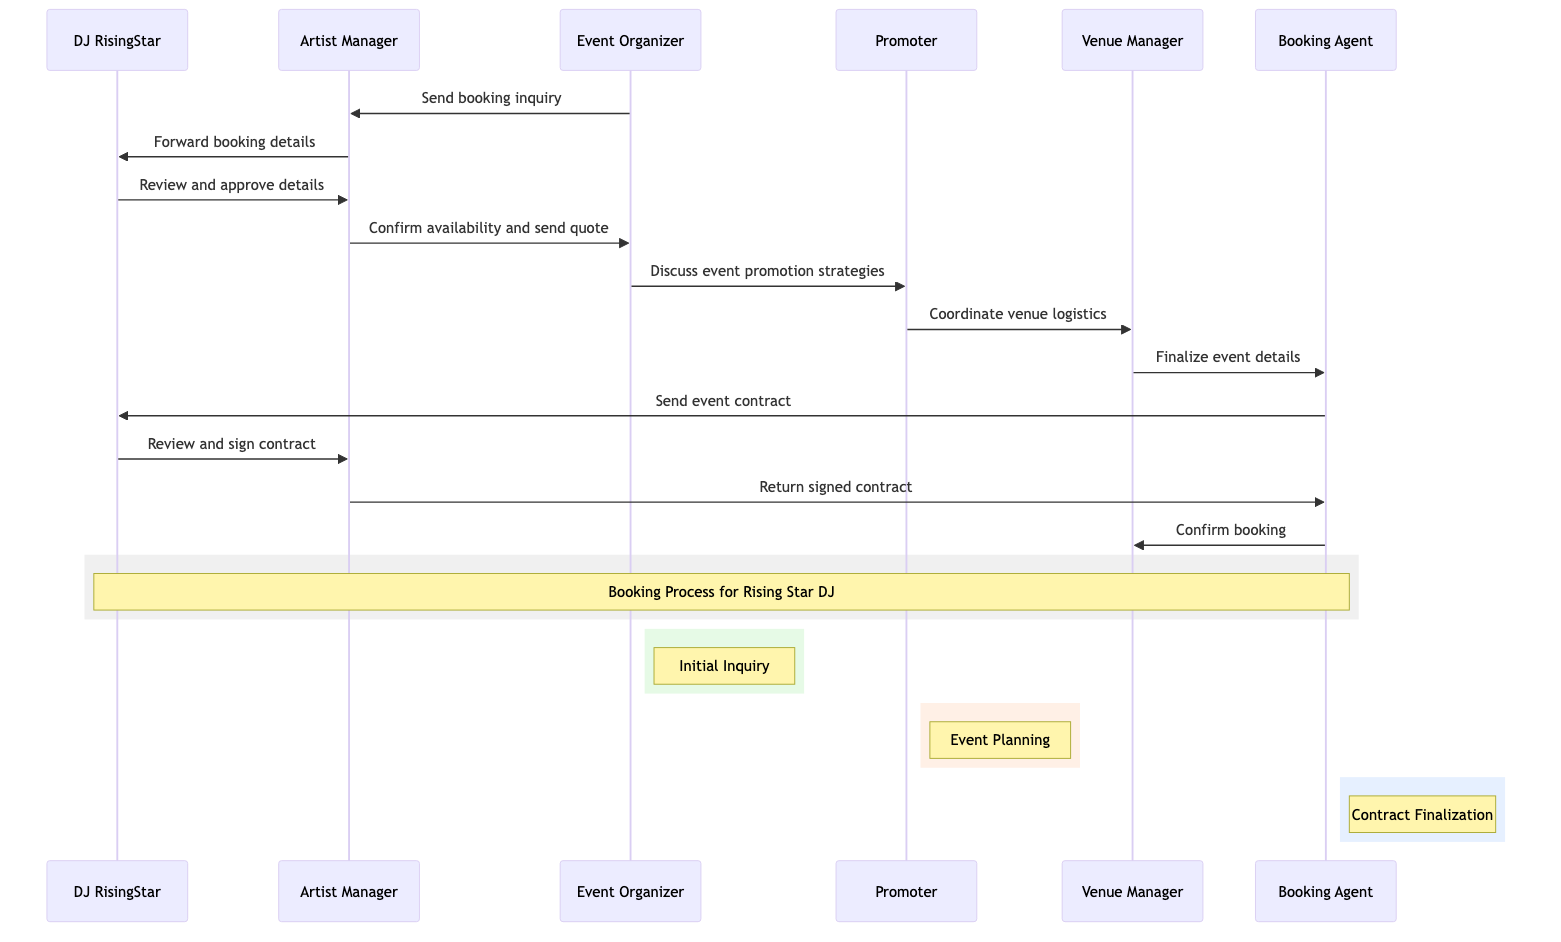What are the participants in the booking process? The participants listed in the diagram are DJ RisingStar, Artist Manager, Event Organizer, Promoter, Venue Manager, and Booking Agent. This information can be obtained directly from the participant section of the sequence diagram.
Answer: DJ RisingStar, Artist Manager, Event Organizer, Promoter, Venue Manager, Booking Agent Who sends the booking inquiry? The diagram indicates that the Event Organizer is the one who sends the booking inquiry to the Artist Manager. This relationship is established by the first message in the sequence.
Answer: Event Organizer How many messages are exchanged in total? By counting the messages listed in the diagram, we can find that there are a total of eleven messages exchanged between the participants in the booking process. This can be verified by simply counting all the arrows in the messages section.
Answer: Eleven What is the last step in the booking process? The final message in the sequence is from the Booking Agent to the Venue Manager confirming the booking. This can be determined by examining the last interaction in the sequence.
Answer: Confirm booking Which participant receives the event contract? The Booking Agent sends the event contract to DJ RisingStar, as indicated by the message directed from Booking Agent to DJ RisingStar. This follows a clear flow of communication in the sequence.
Answer: DJ RisingStar What role does the Promoter play in the booking process? The Promoter discusses event promotion strategies with the Event Organizer and coordinates venue logistics with the Venue Manager, indicating that their role focuses primarily on promotion and logistics. This can be derived from multiple sequential messages involving the Promoter.
Answer: Event promotion How many steps are involved in the approval process for DJ RisingStar? The steps for DJ RisingStar include receiving booking details, reviewing and approving those details, and then reviewing and signing the event contract, totaling three distinct steps in the approval process. This can be traced through the respective messages involving DJ RisingStar.
Answer: Three Which participant finalizes the event details? The Venue Manager is responsible for finalizing the event details before sending the final confirmation to the DJ and the Venue. This is clearly shown between the interaction of Venue Manager and Booking Agent in the sequence.
Answer: Venue Manager What action does the Artist Manager take after DJ RisingStar reviews the contract? The Artist Manager returns the signed contract to the Booking Agent after DJ RisingStar reviews and signs the contract, indicating their centrality in the contractual process. This process is outlined in the messaging sequence.
Answer: Return signed contract 